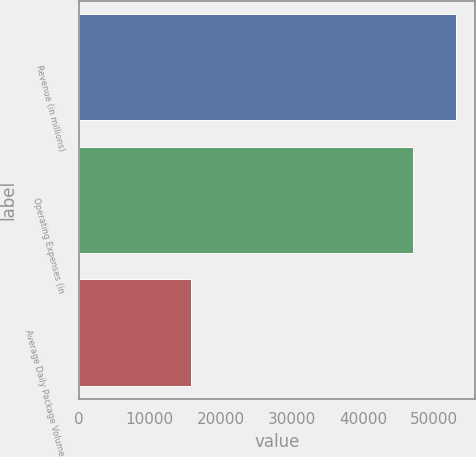<chart> <loc_0><loc_0><loc_500><loc_500><bar_chart><fcel>Revenue (in millions)<fcel>Operating Expenses (in<fcel>Average Daily Package Volume<nl><fcel>53105<fcel>47025<fcel>15797<nl></chart> 